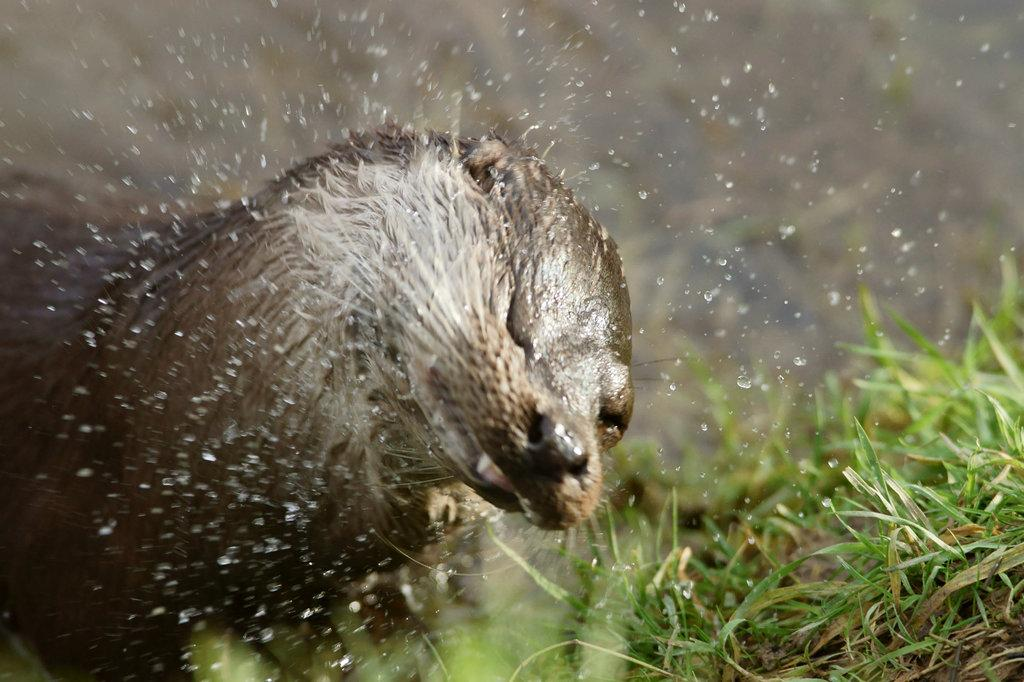What animal is in the picture? There is an otter in the picture. What type of vegetation is on the right side of the picture? There is grass on the right side of the picture. What can be seen around the otter in the image? There are water droplets around the otter. What color is the background of the image? The background of the image is black. How many cats are sitting on the bridge in the image? There are no cats or bridges present in the image; it features an otter and grass. How many chairs are visible in the image? There are no chairs visible in the image. 